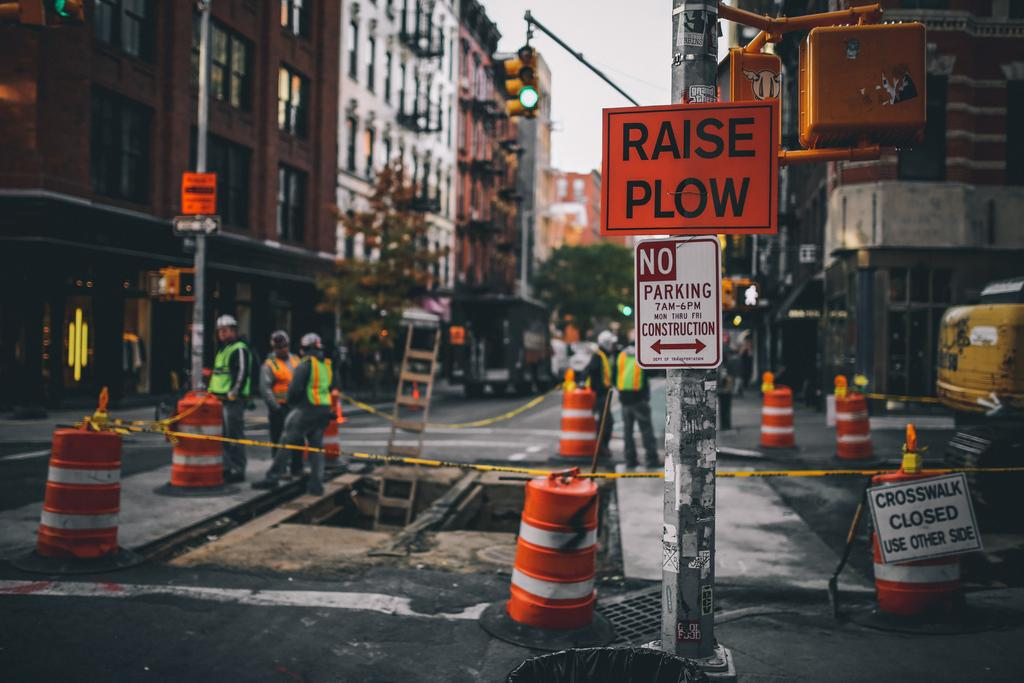<image>
Relay a brief, clear account of the picture shown. Construction workers stand along a hole in a street behind a Raise Plow sign. 